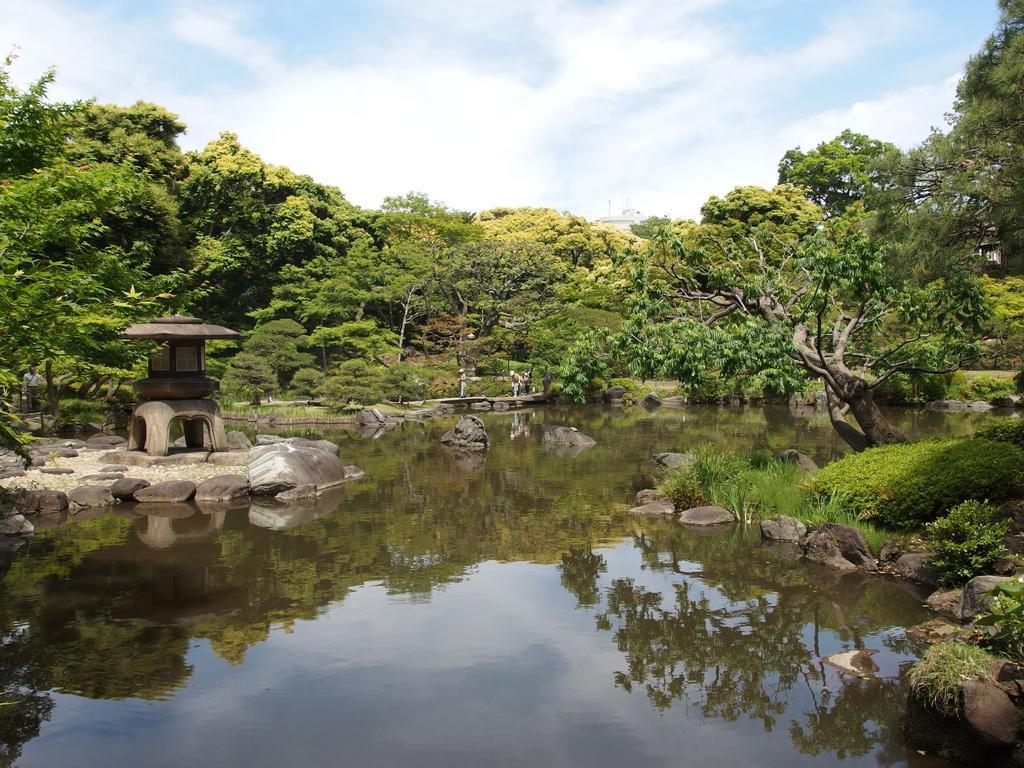In one or two sentences, can you explain what this image depicts? In this picture I can see few trees and few people walking and I can see water and few rocks and I can see a human standing and I can see building in the back and a blue cloudy sky. 